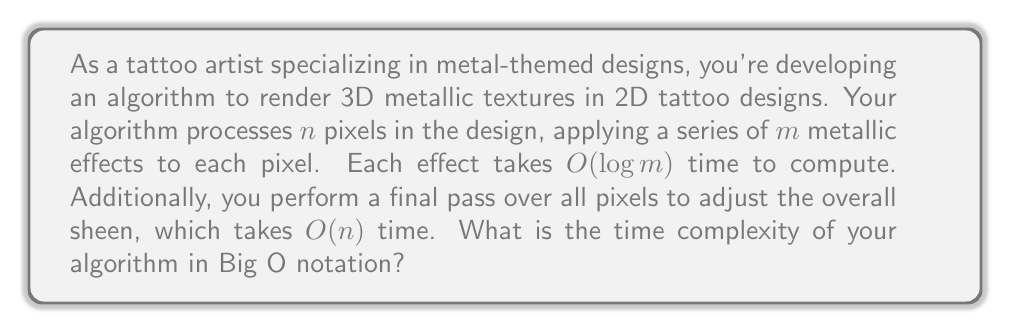Provide a solution to this math problem. Let's break down the algorithm and analyze its time complexity step by step:

1. The algorithm processes $n$ pixels in the design.

2. For each pixel, it applies $m$ metallic effects.

3. Each metallic effect takes $O(\log m)$ time to compute.

4. After processing all pixels with all effects, there's a final pass over all pixels taking $O(n)$ time.

To calculate the total time complexity:

a) For a single pixel, applying all $m$ effects takes:
   $m \cdot O(\log m) = O(m \log m)$ time

b) This is done for all $n$ pixels, so the total time for applying effects is:
   $n \cdot O(m \log m) = O(nm \log m)$

c) The final pass over all pixels adds $O(n)$ time.

Therefore, the total time complexity is:
$O(nm \log m) + O(n)$

Since $O(nm \log m)$ dominates $O(n)$ for any $m > 1$, we can simplify this to:
$O(nm \log m)$

This represents the overall time complexity of the algorithm.
Answer: $O(nm \log m)$ 